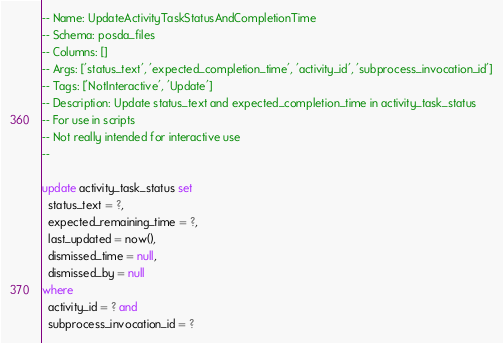<code> <loc_0><loc_0><loc_500><loc_500><_SQL_>-- Name: UpdateActivityTaskStatusAndCompletionTime
-- Schema: posda_files
-- Columns: []
-- Args: ['status_text', 'expected_completion_time', 'activity_id', 'subprocess_invocation_id']
-- Tags: ['NotInteractive', 'Update']
-- Description: Update status_text and expected_completion_time in activity_task_status
-- For use in scripts
-- Not really intended for interactive use
-- 

update activity_task_status set
  status_text = ?,
  expected_remaining_time = ?,
  last_updated = now(),
  dismissed_time = null,
  dismissed_by = null
where
  activity_id = ? and
  subprocess_invocation_id = ?</code> 